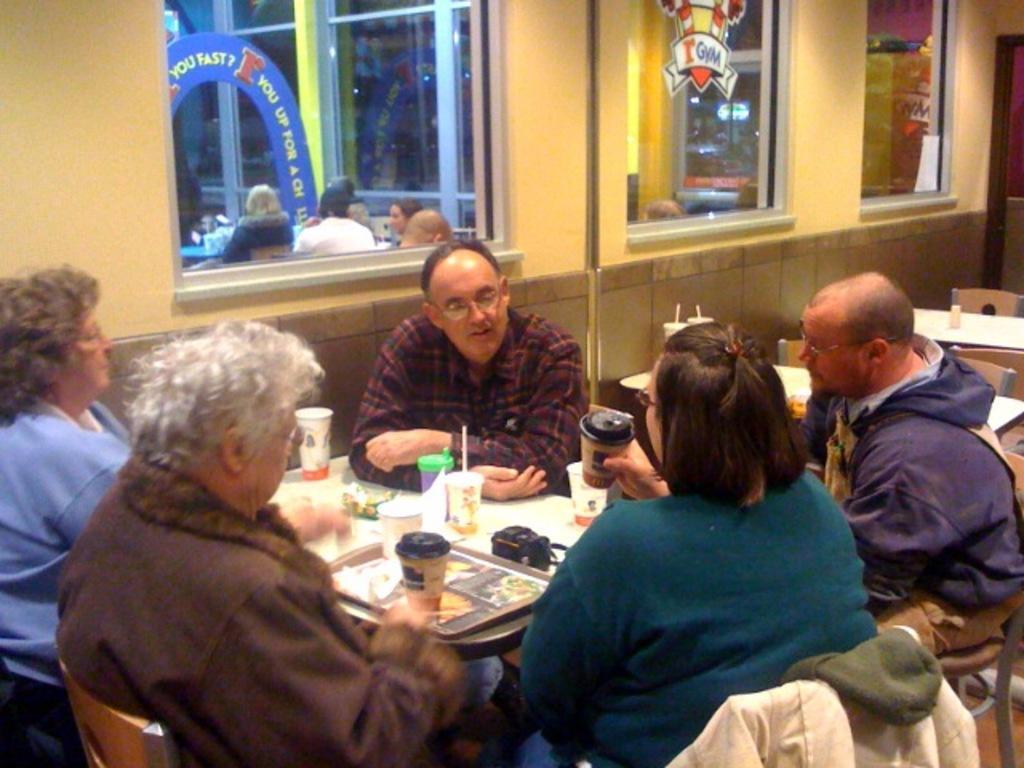Describe this image in one or two sentences. As we can see in the image there is yellow color wall, window, few people sitting on chair and a table. On table there plates, glass and food items. 